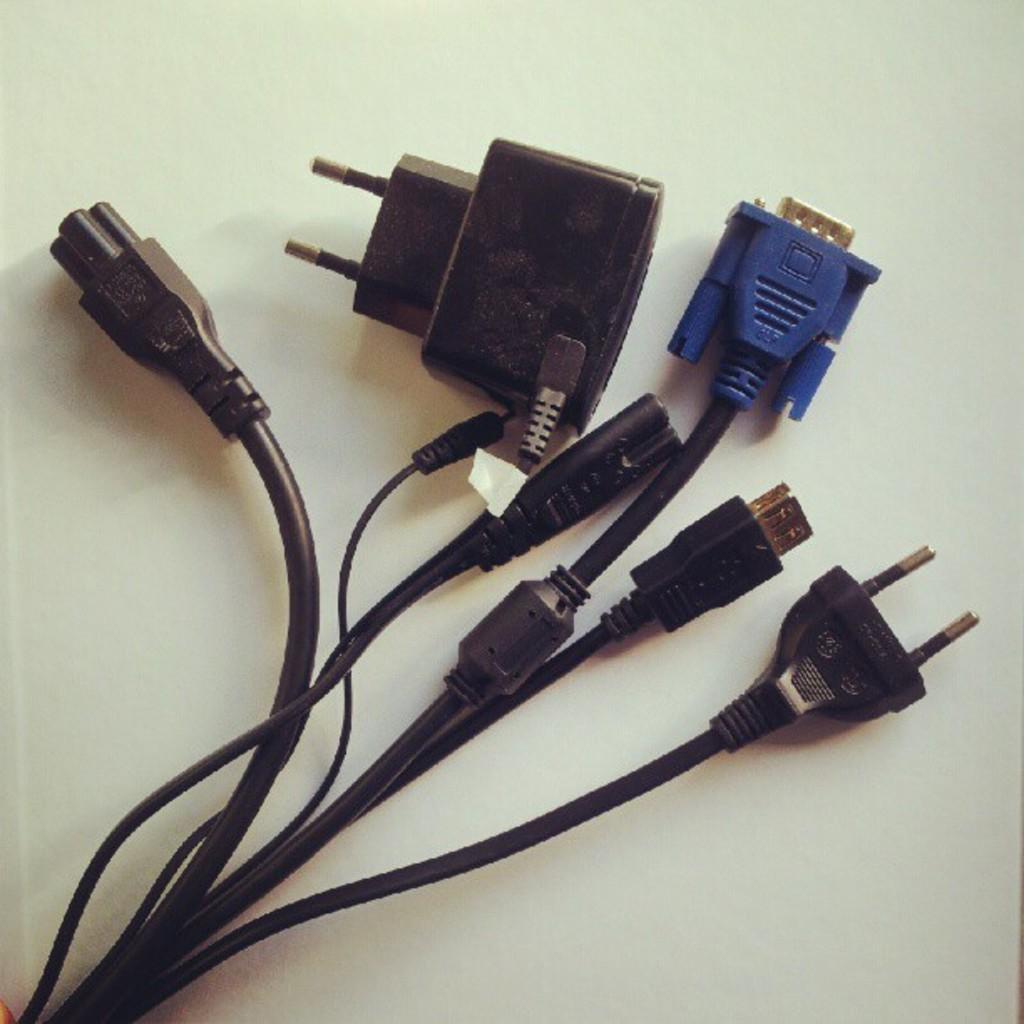Describe this image in one or two sentences. Here in this picture we can see a table, on which we can see number of cable wires present on it over there. 